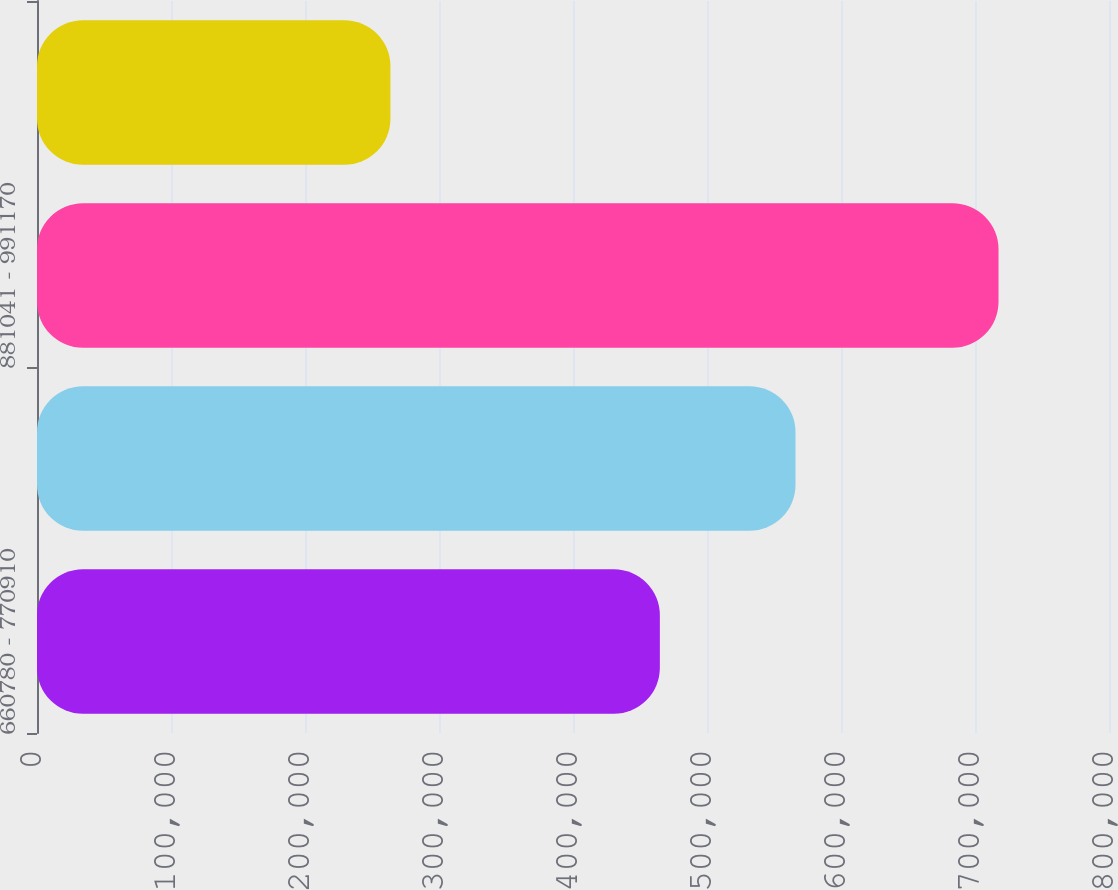Convert chart. <chart><loc_0><loc_0><loc_500><loc_500><bar_chart><fcel>660780 - 770910<fcel>770911 - 881040<fcel>881041 - 991170<fcel>991171 - 1101300<nl><fcel>464810<fcel>566050<fcel>717550<fcel>263754<nl></chart> 